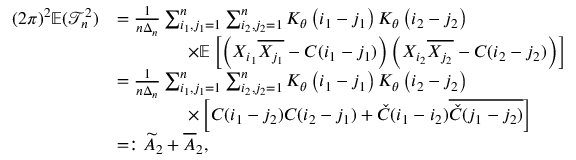Convert formula to latex. <formula><loc_0><loc_0><loc_500><loc_500>\begin{array} { r l } { ( 2 \pi ) ^ { 2 } \mathbb { E } ( \mathcal { T } _ { n } ^ { 2 } ) } & { = \frac { 1 } { n \Delta _ { n } } \sum _ { i _ { 1 } , j _ { 1 } = 1 } ^ { n } \sum _ { i _ { 2 } , j _ { 2 } = 1 } ^ { n } K _ { \theta } \left ( i _ { 1 } - j _ { 1 } \right ) K _ { \theta } \left ( i _ { 2 } - j _ { 2 } \right ) } \\ & { \quad \times \mathbb { E } \left [ \left ( X _ { i _ { 1 } } \overline { { X _ { j _ { 1 } } } } - C ( i _ { 1 } - j _ { 1 } ) \right ) \left ( X _ { i _ { 2 } } \overline { { X _ { j _ { 2 } } } } - C ( i _ { 2 } - j _ { 2 } ) \right ) \right ] } \\ & { = \frac { 1 } { n \Delta _ { n } } \sum _ { i _ { 1 } , j _ { 1 } = 1 } ^ { n } \sum _ { i _ { 2 } , j _ { 2 } = 1 } ^ { n } K _ { \theta } \left ( i _ { 1 } - j _ { 1 } \right ) K _ { \theta } \left ( i _ { 2 } - j _ { 2 } \right ) } \\ & { \quad \times \left [ C ( i _ { 1 } - j _ { 2 } ) C ( i _ { 2 } - j _ { 1 } ) + \check { C } ( i _ { 1 } - i _ { 2 } ) \overline { { \check { C } ( j _ { 1 } - j _ { 2 } ) } } \right ] } \\ & { = \colon \widetilde { A } _ { 2 } + \overline { A } _ { 2 } , } \end{array}</formula> 